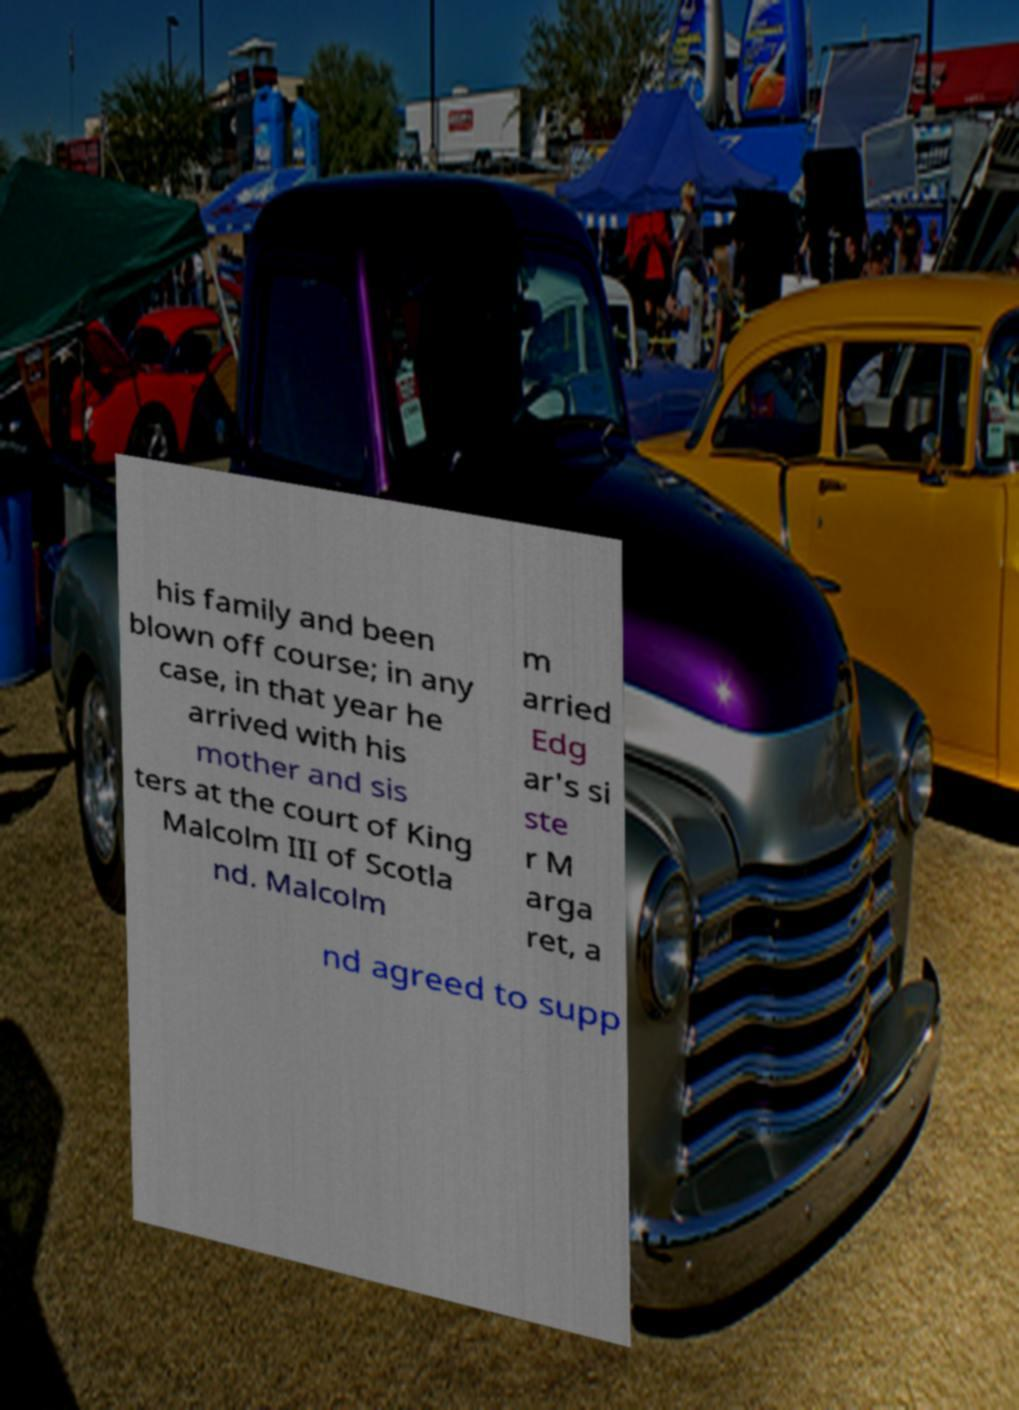Could you assist in decoding the text presented in this image and type it out clearly? his family and been blown off course; in any case, in that year he arrived with his mother and sis ters at the court of King Malcolm III of Scotla nd. Malcolm m arried Edg ar's si ste r M arga ret, a nd agreed to supp 